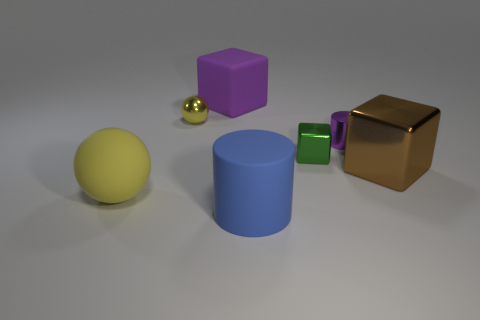Is there anything else of the same color as the big cylinder?
Ensure brevity in your answer.  No. Do the large rubber thing behind the brown metal object and the large blue matte object have the same shape?
Your response must be concise. No. Is the shape of the blue thing the same as the tiny object that is on the left side of the big blue cylinder?
Provide a succinct answer. No. What color is the tiny cylinder?
Keep it short and to the point. Purple. Are the small yellow sphere and the block behind the small metallic cylinder made of the same material?
Ensure brevity in your answer.  No. What shape is the tiny yellow thing that is made of the same material as the green object?
Offer a very short reply. Sphere. The metallic object that is the same size as the matte sphere is what color?
Your answer should be very brief. Brown. There is a green metal block to the right of the yellow metallic object; does it have the same size as the big metal block?
Your response must be concise. No. Is the color of the tiny ball the same as the large sphere?
Your answer should be very brief. Yes. How many brown shiny objects are there?
Your response must be concise. 1. 